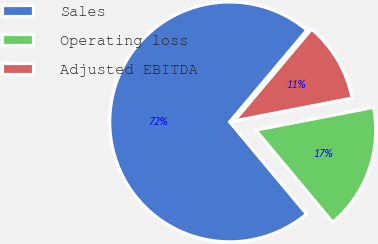Convert chart to OTSL. <chart><loc_0><loc_0><loc_500><loc_500><pie_chart><fcel>Sales<fcel>Operating loss<fcel>Adjusted EBITDA<nl><fcel>72.2%<fcel>16.97%<fcel>10.83%<nl></chart> 